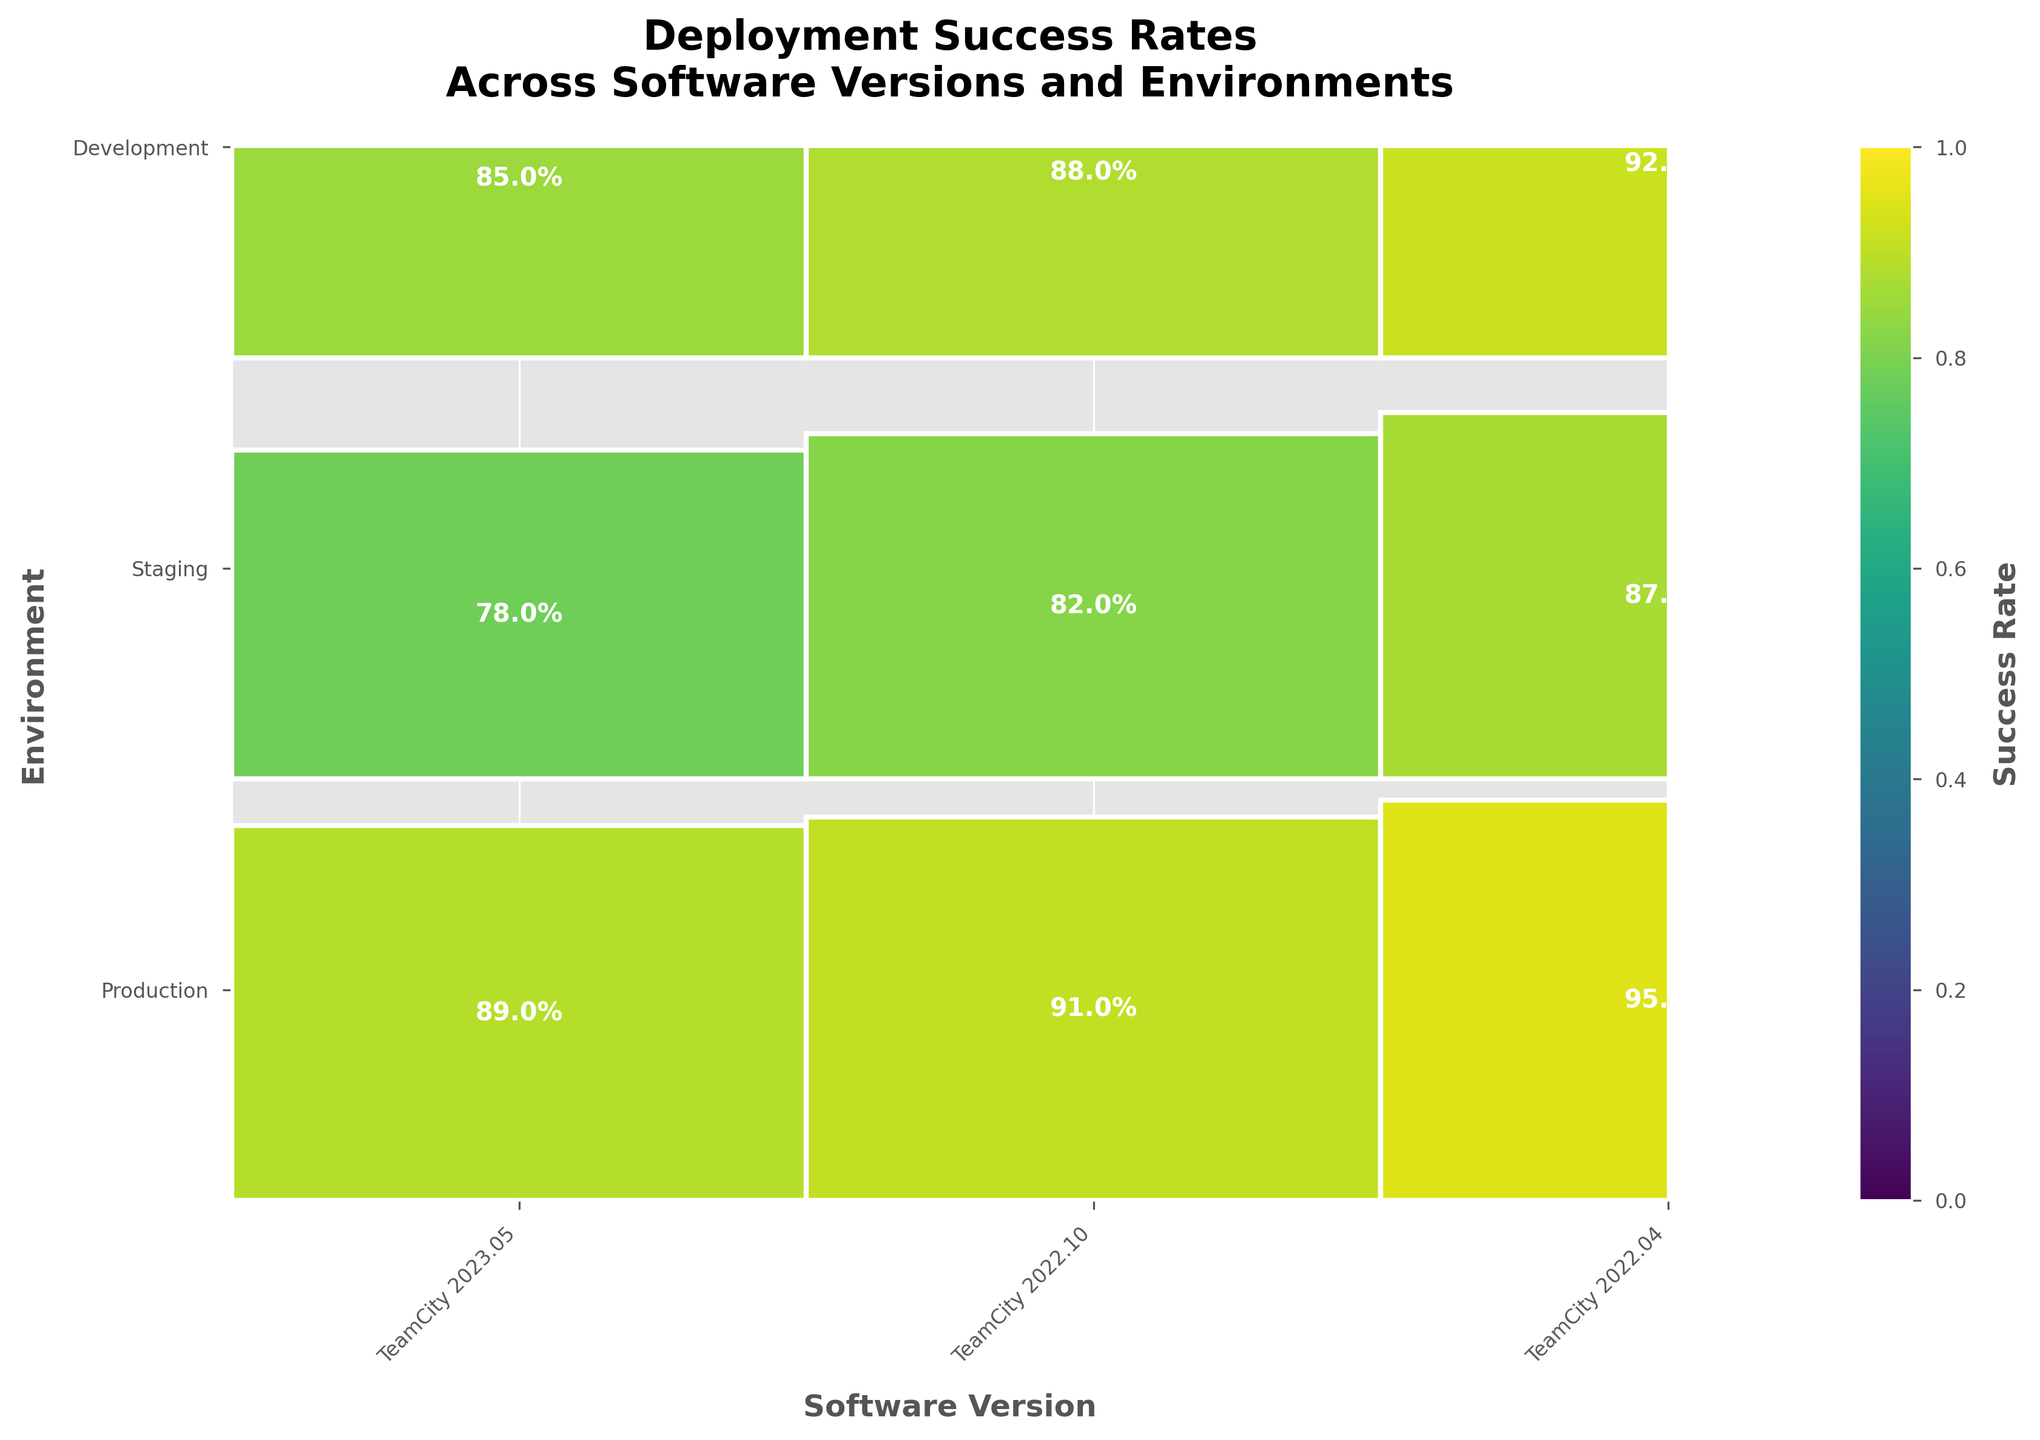What's the title of the figure? The title is located at the top of the figure and clearly states the purpose or main topic the figure is addressing.
Answer: Deployment Success Rates Across Software Versions and Environments How is the success rate color-coded in the figure? The color coding uses a gradient scale from light to dark to represent success rates, where darker shades indicate higher success rates. This can be inferred by the color bar usually found at the side or bottom of mosaic plots.
Answer: Darker shades indicate higher success rates What is the success rate for TeamCity 2023.05 in the Development environment? Find the rectangle corresponding to TeamCity 2023.05 and Development environment in the mosaic plot. The percentage is displayed within the rectangle.
Answer: 95% Which software version has the highest success rate in the Production environment? Compare the success rates for the Production environment across all software versions. The rectangle with the darkest shade and highest percentage will be the highest.
Answer: TeamCity 2023.05 Is there a version where the success rate in Staging is less than in Development but more than in Production? To answer this, examine the success rates for each version in the Staging and Development environments and ensure Staging is more than Production but less than Development for the same version.
Answer: No What's the average success rate for TeamCity 2022.04 across all environments? Add the success rates for TeamCity 2022.04 across all environments and divide by the number of environments (3). (78% + 85% + 89%)/3
Answer: 84% Which environment consistently shows the highest success rates across all software versions? Compare the success rates within each environment (Production, Staging, Development) for the different software versions. The environment with the consistently higher percentages is the answer.
Answer: Development What's the difference in success rates between Production and Staging for TeamCity 2023.05? Subtract the success rate of Staging from that of Production for TeamCity 2023.05. 92% - 87%
Answer: 5% Which software version has the most balanced success rates across all environments, meaning the least variation in success rates? Calculate the variation in success rates (i.e., the range) across environments for each version. The version with the smallest range has the most balanced success rates.
Answer: TeamCity 2022.10 